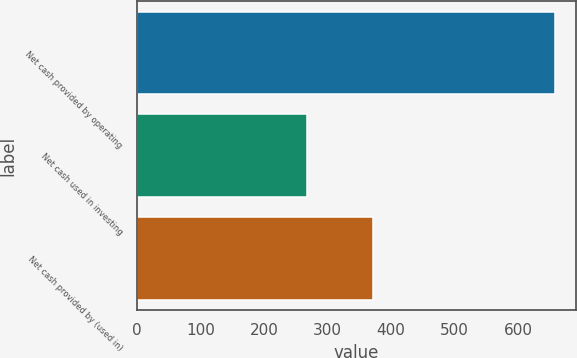Convert chart to OTSL. <chart><loc_0><loc_0><loc_500><loc_500><bar_chart><fcel>Net cash provided by operating<fcel>Net cash used in investing<fcel>Net cash provided by (used in)<nl><fcel>658.1<fcel>267.1<fcel>371.5<nl></chart> 